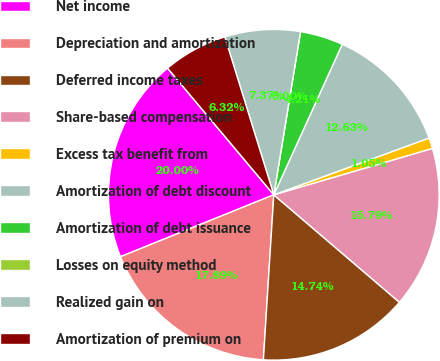Convert chart. <chart><loc_0><loc_0><loc_500><loc_500><pie_chart><fcel>Net income<fcel>Depreciation and amortization<fcel>Deferred income taxes<fcel>Share-based compensation<fcel>Excess tax benefit from<fcel>Amortization of debt discount<fcel>Amortization of debt issuance<fcel>Losses on equity method<fcel>Realized gain on<fcel>Amortization of premium on<nl><fcel>20.0%<fcel>17.89%<fcel>14.74%<fcel>15.79%<fcel>1.05%<fcel>12.63%<fcel>4.21%<fcel>0.0%<fcel>7.37%<fcel>6.32%<nl></chart> 